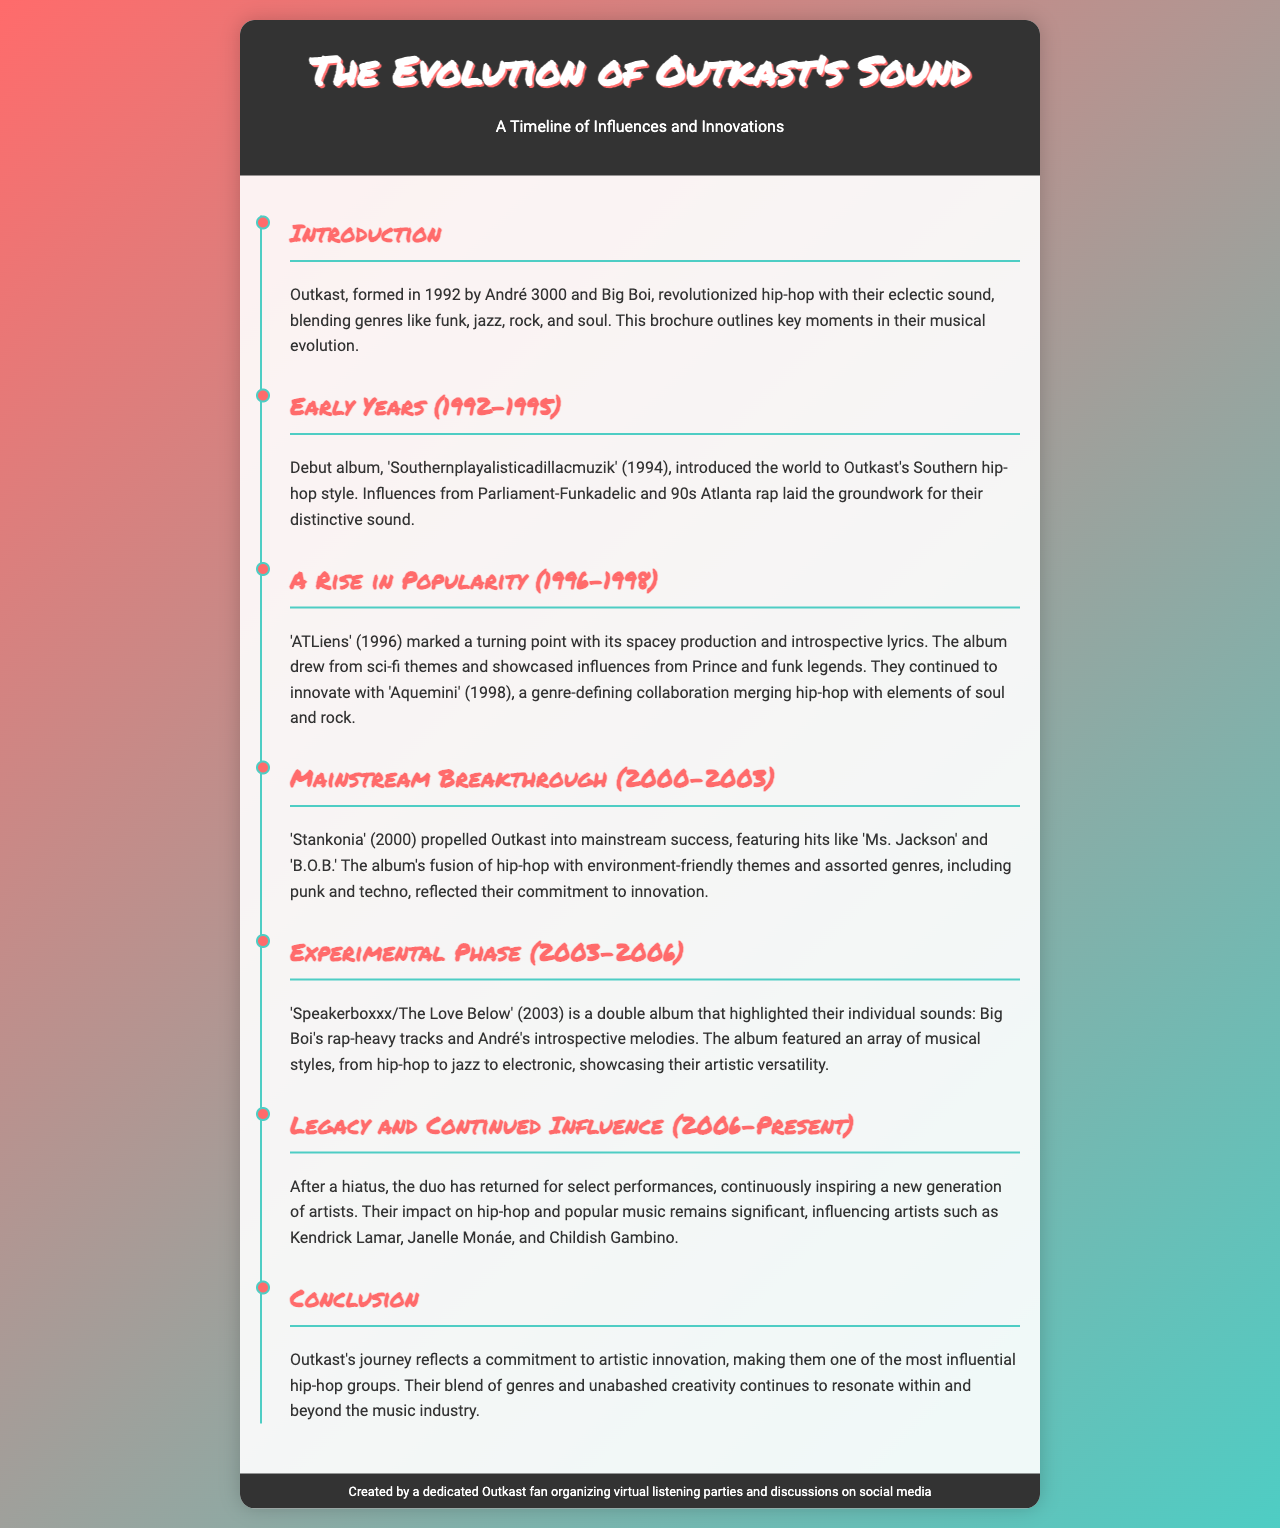what year was Outkast formed? The document states that Outkast was formed in 1992.
Answer: 1992 what is the title of Outkast's debut album? The debut album of Outkast is titled 'Southernplayalisticadillacmuzik'.
Answer: Southernplayalisticadillacmuzik which album marked a turning point for Outkast? The album that marked a turning point for Outkast is 'ATLiens'.
Answer: ATLiens what genre did 'Stankonia' blend with hip-hop? 'Stankonia' blended hip-hop with punk and techno genres.
Answer: punk and techno what is the main theme of 'Speakerboxxx/The Love Below'? The main theme is the individual sounds of Big Boi and André 3000.
Answer: individual sounds who are some artists influenced by Outkast? The document lists Kendrick Lamar, Janelle Monáe, and Childish Gambino as artists they influenced.
Answer: Kendrick Lamar, Janelle Monáe, and Childish Gambino in what year was 'Aquemini' released? 'Aquemini' was released in 1998.
Answer: 1998 what was a significant feature of 'Stankonia' in terms of lyrics? A significant feature was the inclusion of environment-friendly themes.
Answer: environment-friendly themes what type of document is this? This document is a brochure about Outkast's musical evolution.
Answer: brochure 